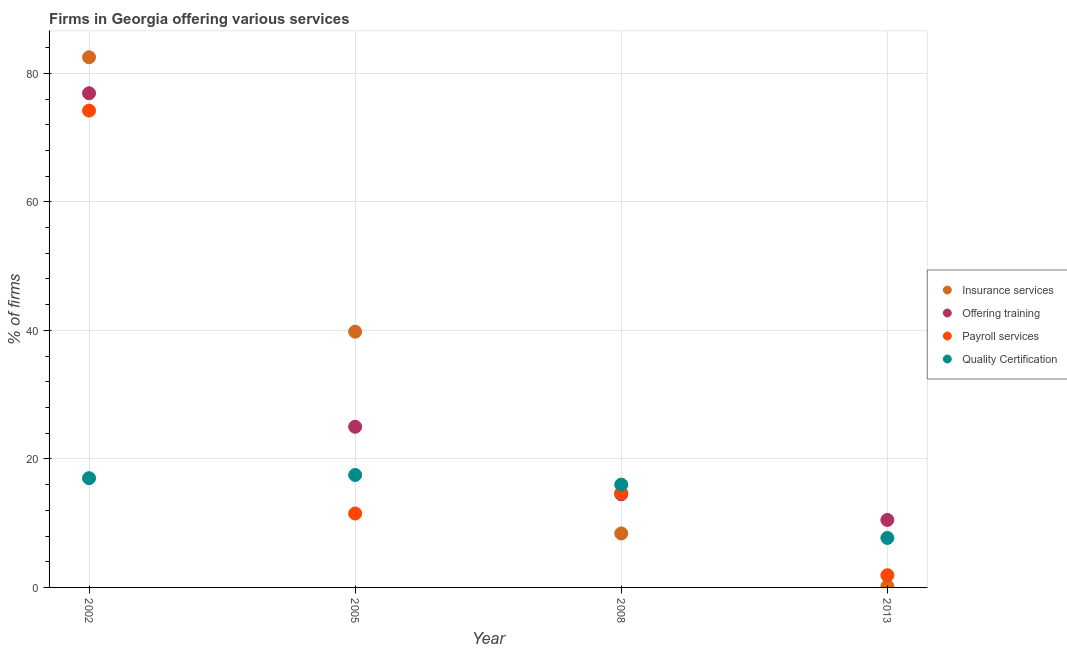Is the number of dotlines equal to the number of legend labels?
Ensure brevity in your answer.  Yes. Across all years, what is the maximum percentage of firms offering payroll services?
Your answer should be compact. 74.2. Across all years, what is the minimum percentage of firms offering insurance services?
Provide a short and direct response. 0.2. In which year was the percentage of firms offering quality certification maximum?
Ensure brevity in your answer.  2005. What is the total percentage of firms offering training in the graph?
Provide a short and direct response. 126.9. What is the difference between the percentage of firms offering insurance services in 2002 and that in 2013?
Make the answer very short. 82.3. What is the difference between the percentage of firms offering insurance services in 2002 and the percentage of firms offering payroll services in 2008?
Offer a very short reply. 67.8. What is the average percentage of firms offering quality certification per year?
Your answer should be compact. 14.55. In the year 2013, what is the difference between the percentage of firms offering insurance services and percentage of firms offering training?
Your answer should be compact. -10.3. What is the ratio of the percentage of firms offering payroll services in 2008 to that in 2013?
Keep it short and to the point. 7.74. What is the difference between the highest and the second highest percentage of firms offering training?
Offer a terse response. 51.9. In how many years, is the percentage of firms offering payroll services greater than the average percentage of firms offering payroll services taken over all years?
Give a very brief answer. 1. Is the sum of the percentage of firms offering training in 2002 and 2013 greater than the maximum percentage of firms offering quality certification across all years?
Make the answer very short. Yes. Does the percentage of firms offering training monotonically increase over the years?
Your answer should be very brief. No. Is the percentage of firms offering training strictly greater than the percentage of firms offering quality certification over the years?
Ensure brevity in your answer.  No. Is the percentage of firms offering insurance services strictly less than the percentage of firms offering quality certification over the years?
Make the answer very short. No. How many years are there in the graph?
Your answer should be very brief. 4. What is the difference between two consecutive major ticks on the Y-axis?
Provide a succinct answer. 20. Are the values on the major ticks of Y-axis written in scientific E-notation?
Make the answer very short. No. Does the graph contain any zero values?
Keep it short and to the point. No. Does the graph contain grids?
Your answer should be compact. Yes. Where does the legend appear in the graph?
Offer a terse response. Center right. How are the legend labels stacked?
Ensure brevity in your answer.  Vertical. What is the title of the graph?
Your response must be concise. Firms in Georgia offering various services . What is the label or title of the Y-axis?
Offer a terse response. % of firms. What is the % of firms in Insurance services in 2002?
Offer a very short reply. 82.5. What is the % of firms of Offering training in 2002?
Your answer should be compact. 76.9. What is the % of firms of Payroll services in 2002?
Give a very brief answer. 74.2. What is the % of firms in Insurance services in 2005?
Offer a very short reply. 39.8. What is the % of firms of Payroll services in 2005?
Provide a short and direct response. 11.5. What is the % of firms in Insurance services in 2008?
Your answer should be very brief. 8.4. What is the % of firms of Quality Certification in 2008?
Provide a succinct answer. 16. What is the % of firms of Insurance services in 2013?
Provide a short and direct response. 0.2. What is the % of firms in Offering training in 2013?
Offer a very short reply. 10.5. Across all years, what is the maximum % of firms of Insurance services?
Make the answer very short. 82.5. Across all years, what is the maximum % of firms in Offering training?
Your answer should be compact. 76.9. Across all years, what is the maximum % of firms in Payroll services?
Your response must be concise. 74.2. Across all years, what is the maximum % of firms of Quality Certification?
Offer a very short reply. 17.5. Across all years, what is the minimum % of firms of Insurance services?
Offer a very short reply. 0.2. Across all years, what is the minimum % of firms in Payroll services?
Provide a short and direct response. 1.9. What is the total % of firms of Insurance services in the graph?
Make the answer very short. 130.9. What is the total % of firms in Offering training in the graph?
Provide a succinct answer. 126.9. What is the total % of firms in Payroll services in the graph?
Provide a succinct answer. 102.3. What is the total % of firms in Quality Certification in the graph?
Make the answer very short. 58.2. What is the difference between the % of firms in Insurance services in 2002 and that in 2005?
Your response must be concise. 42.7. What is the difference between the % of firms in Offering training in 2002 and that in 2005?
Ensure brevity in your answer.  51.9. What is the difference between the % of firms in Payroll services in 2002 and that in 2005?
Keep it short and to the point. 62.7. What is the difference between the % of firms of Quality Certification in 2002 and that in 2005?
Your answer should be very brief. -0.5. What is the difference between the % of firms in Insurance services in 2002 and that in 2008?
Your answer should be compact. 74.1. What is the difference between the % of firms of Offering training in 2002 and that in 2008?
Offer a very short reply. 62.4. What is the difference between the % of firms of Payroll services in 2002 and that in 2008?
Provide a short and direct response. 59.5. What is the difference between the % of firms in Quality Certification in 2002 and that in 2008?
Offer a very short reply. 1. What is the difference between the % of firms in Insurance services in 2002 and that in 2013?
Ensure brevity in your answer.  82.3. What is the difference between the % of firms in Offering training in 2002 and that in 2013?
Your response must be concise. 66.4. What is the difference between the % of firms of Payroll services in 2002 and that in 2013?
Offer a terse response. 72.3. What is the difference between the % of firms in Insurance services in 2005 and that in 2008?
Your answer should be very brief. 31.4. What is the difference between the % of firms of Offering training in 2005 and that in 2008?
Ensure brevity in your answer.  10.5. What is the difference between the % of firms of Insurance services in 2005 and that in 2013?
Make the answer very short. 39.6. What is the difference between the % of firms in Offering training in 2005 and that in 2013?
Offer a very short reply. 14.5. What is the difference between the % of firms of Insurance services in 2008 and that in 2013?
Provide a succinct answer. 8.2. What is the difference between the % of firms of Insurance services in 2002 and the % of firms of Offering training in 2005?
Offer a very short reply. 57.5. What is the difference between the % of firms of Insurance services in 2002 and the % of firms of Payroll services in 2005?
Provide a short and direct response. 71. What is the difference between the % of firms of Offering training in 2002 and the % of firms of Payroll services in 2005?
Your answer should be compact. 65.4. What is the difference between the % of firms of Offering training in 2002 and the % of firms of Quality Certification in 2005?
Keep it short and to the point. 59.4. What is the difference between the % of firms of Payroll services in 2002 and the % of firms of Quality Certification in 2005?
Ensure brevity in your answer.  56.7. What is the difference between the % of firms in Insurance services in 2002 and the % of firms in Offering training in 2008?
Make the answer very short. 68. What is the difference between the % of firms in Insurance services in 2002 and the % of firms in Payroll services in 2008?
Give a very brief answer. 67.8. What is the difference between the % of firms of Insurance services in 2002 and the % of firms of Quality Certification in 2008?
Ensure brevity in your answer.  66.5. What is the difference between the % of firms in Offering training in 2002 and the % of firms in Payroll services in 2008?
Your answer should be compact. 62.2. What is the difference between the % of firms of Offering training in 2002 and the % of firms of Quality Certification in 2008?
Your response must be concise. 60.9. What is the difference between the % of firms of Payroll services in 2002 and the % of firms of Quality Certification in 2008?
Ensure brevity in your answer.  58.2. What is the difference between the % of firms in Insurance services in 2002 and the % of firms in Offering training in 2013?
Your answer should be very brief. 72. What is the difference between the % of firms of Insurance services in 2002 and the % of firms of Payroll services in 2013?
Your answer should be compact. 80.6. What is the difference between the % of firms of Insurance services in 2002 and the % of firms of Quality Certification in 2013?
Your response must be concise. 74.8. What is the difference between the % of firms in Offering training in 2002 and the % of firms in Payroll services in 2013?
Ensure brevity in your answer.  75. What is the difference between the % of firms in Offering training in 2002 and the % of firms in Quality Certification in 2013?
Provide a short and direct response. 69.2. What is the difference between the % of firms in Payroll services in 2002 and the % of firms in Quality Certification in 2013?
Your response must be concise. 66.5. What is the difference between the % of firms in Insurance services in 2005 and the % of firms in Offering training in 2008?
Offer a very short reply. 25.3. What is the difference between the % of firms in Insurance services in 2005 and the % of firms in Payroll services in 2008?
Give a very brief answer. 25.1. What is the difference between the % of firms of Insurance services in 2005 and the % of firms of Quality Certification in 2008?
Your response must be concise. 23.8. What is the difference between the % of firms in Offering training in 2005 and the % of firms in Payroll services in 2008?
Provide a succinct answer. 10.3. What is the difference between the % of firms in Offering training in 2005 and the % of firms in Quality Certification in 2008?
Keep it short and to the point. 9. What is the difference between the % of firms of Payroll services in 2005 and the % of firms of Quality Certification in 2008?
Provide a succinct answer. -4.5. What is the difference between the % of firms in Insurance services in 2005 and the % of firms in Offering training in 2013?
Give a very brief answer. 29.3. What is the difference between the % of firms in Insurance services in 2005 and the % of firms in Payroll services in 2013?
Your answer should be very brief. 37.9. What is the difference between the % of firms in Insurance services in 2005 and the % of firms in Quality Certification in 2013?
Your answer should be very brief. 32.1. What is the difference between the % of firms in Offering training in 2005 and the % of firms in Payroll services in 2013?
Offer a terse response. 23.1. What is the difference between the % of firms of Payroll services in 2005 and the % of firms of Quality Certification in 2013?
Provide a succinct answer. 3.8. What is the difference between the % of firms in Insurance services in 2008 and the % of firms in Offering training in 2013?
Give a very brief answer. -2.1. What is the difference between the % of firms of Insurance services in 2008 and the % of firms of Payroll services in 2013?
Make the answer very short. 6.5. What is the difference between the % of firms in Insurance services in 2008 and the % of firms in Quality Certification in 2013?
Your answer should be very brief. 0.7. What is the difference between the % of firms of Offering training in 2008 and the % of firms of Quality Certification in 2013?
Offer a very short reply. 6.8. What is the average % of firms in Insurance services per year?
Offer a very short reply. 32.73. What is the average % of firms of Offering training per year?
Ensure brevity in your answer.  31.73. What is the average % of firms of Payroll services per year?
Keep it short and to the point. 25.57. What is the average % of firms in Quality Certification per year?
Your response must be concise. 14.55. In the year 2002, what is the difference between the % of firms in Insurance services and % of firms in Offering training?
Provide a succinct answer. 5.6. In the year 2002, what is the difference between the % of firms of Insurance services and % of firms of Payroll services?
Keep it short and to the point. 8.3. In the year 2002, what is the difference between the % of firms in Insurance services and % of firms in Quality Certification?
Your answer should be very brief. 65.5. In the year 2002, what is the difference between the % of firms in Offering training and % of firms in Payroll services?
Your answer should be compact. 2.7. In the year 2002, what is the difference between the % of firms in Offering training and % of firms in Quality Certification?
Provide a succinct answer. 59.9. In the year 2002, what is the difference between the % of firms of Payroll services and % of firms of Quality Certification?
Offer a very short reply. 57.2. In the year 2005, what is the difference between the % of firms in Insurance services and % of firms in Offering training?
Your answer should be compact. 14.8. In the year 2005, what is the difference between the % of firms of Insurance services and % of firms of Payroll services?
Provide a short and direct response. 28.3. In the year 2005, what is the difference between the % of firms in Insurance services and % of firms in Quality Certification?
Provide a succinct answer. 22.3. In the year 2005, what is the difference between the % of firms in Offering training and % of firms in Payroll services?
Offer a terse response. 13.5. In the year 2008, what is the difference between the % of firms of Insurance services and % of firms of Offering training?
Offer a terse response. -6.1. In the year 2008, what is the difference between the % of firms of Offering training and % of firms of Payroll services?
Your answer should be very brief. -0.2. In the year 2013, what is the difference between the % of firms in Insurance services and % of firms in Offering training?
Your answer should be very brief. -10.3. In the year 2013, what is the difference between the % of firms of Insurance services and % of firms of Payroll services?
Make the answer very short. -1.7. In the year 2013, what is the difference between the % of firms of Payroll services and % of firms of Quality Certification?
Give a very brief answer. -5.8. What is the ratio of the % of firms of Insurance services in 2002 to that in 2005?
Keep it short and to the point. 2.07. What is the ratio of the % of firms in Offering training in 2002 to that in 2005?
Provide a succinct answer. 3.08. What is the ratio of the % of firms of Payroll services in 2002 to that in 2005?
Make the answer very short. 6.45. What is the ratio of the % of firms of Quality Certification in 2002 to that in 2005?
Provide a succinct answer. 0.97. What is the ratio of the % of firms in Insurance services in 2002 to that in 2008?
Your answer should be very brief. 9.82. What is the ratio of the % of firms in Offering training in 2002 to that in 2008?
Make the answer very short. 5.3. What is the ratio of the % of firms in Payroll services in 2002 to that in 2008?
Your response must be concise. 5.05. What is the ratio of the % of firms in Insurance services in 2002 to that in 2013?
Make the answer very short. 412.5. What is the ratio of the % of firms of Offering training in 2002 to that in 2013?
Provide a short and direct response. 7.32. What is the ratio of the % of firms in Payroll services in 2002 to that in 2013?
Give a very brief answer. 39.05. What is the ratio of the % of firms in Quality Certification in 2002 to that in 2013?
Give a very brief answer. 2.21. What is the ratio of the % of firms of Insurance services in 2005 to that in 2008?
Your response must be concise. 4.74. What is the ratio of the % of firms of Offering training in 2005 to that in 2008?
Provide a succinct answer. 1.72. What is the ratio of the % of firms in Payroll services in 2005 to that in 2008?
Provide a short and direct response. 0.78. What is the ratio of the % of firms in Quality Certification in 2005 to that in 2008?
Give a very brief answer. 1.09. What is the ratio of the % of firms of Insurance services in 2005 to that in 2013?
Make the answer very short. 199. What is the ratio of the % of firms in Offering training in 2005 to that in 2013?
Your answer should be very brief. 2.38. What is the ratio of the % of firms of Payroll services in 2005 to that in 2013?
Offer a very short reply. 6.05. What is the ratio of the % of firms in Quality Certification in 2005 to that in 2013?
Your answer should be very brief. 2.27. What is the ratio of the % of firms of Offering training in 2008 to that in 2013?
Make the answer very short. 1.38. What is the ratio of the % of firms of Payroll services in 2008 to that in 2013?
Provide a succinct answer. 7.74. What is the ratio of the % of firms in Quality Certification in 2008 to that in 2013?
Your response must be concise. 2.08. What is the difference between the highest and the second highest % of firms of Insurance services?
Make the answer very short. 42.7. What is the difference between the highest and the second highest % of firms in Offering training?
Your answer should be compact. 51.9. What is the difference between the highest and the second highest % of firms of Payroll services?
Your answer should be compact. 59.5. What is the difference between the highest and the second highest % of firms of Quality Certification?
Give a very brief answer. 0.5. What is the difference between the highest and the lowest % of firms of Insurance services?
Provide a succinct answer. 82.3. What is the difference between the highest and the lowest % of firms in Offering training?
Keep it short and to the point. 66.4. What is the difference between the highest and the lowest % of firms of Payroll services?
Your response must be concise. 72.3. What is the difference between the highest and the lowest % of firms in Quality Certification?
Offer a very short reply. 9.8. 